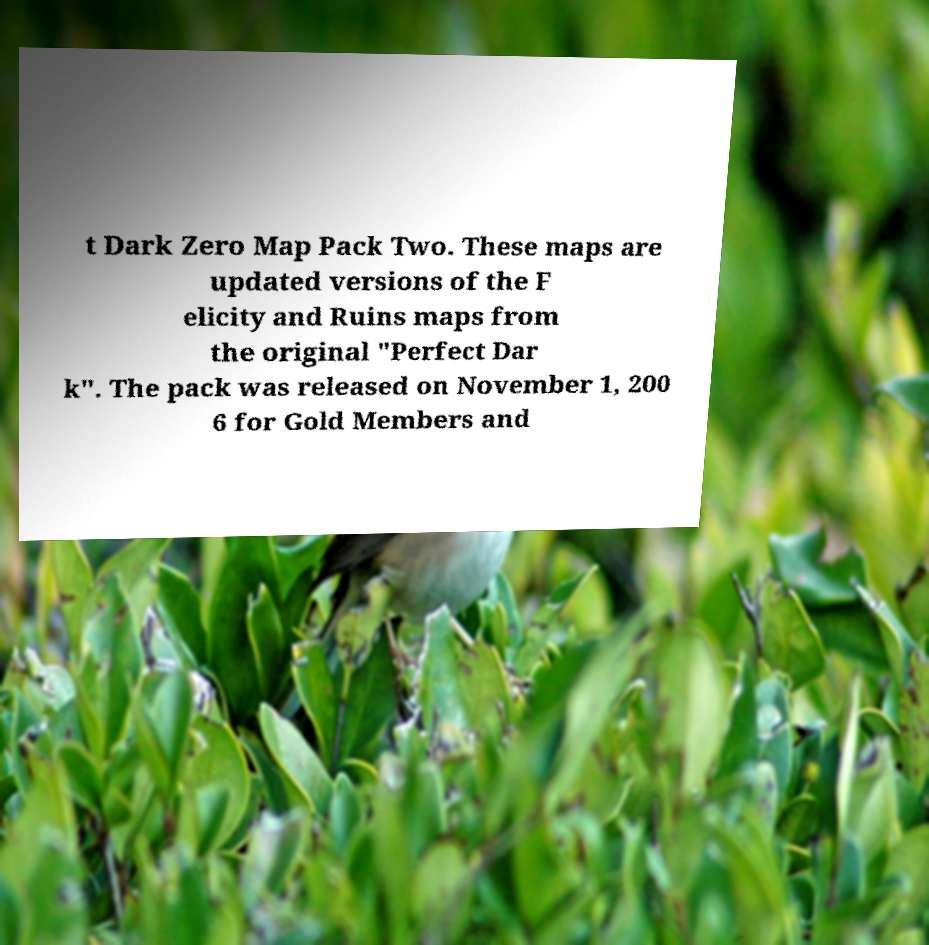Can you read and provide the text displayed in the image?This photo seems to have some interesting text. Can you extract and type it out for me? t Dark Zero Map Pack Two. These maps are updated versions of the F elicity and Ruins maps from the original "Perfect Dar k". The pack was released on November 1, 200 6 for Gold Members and 